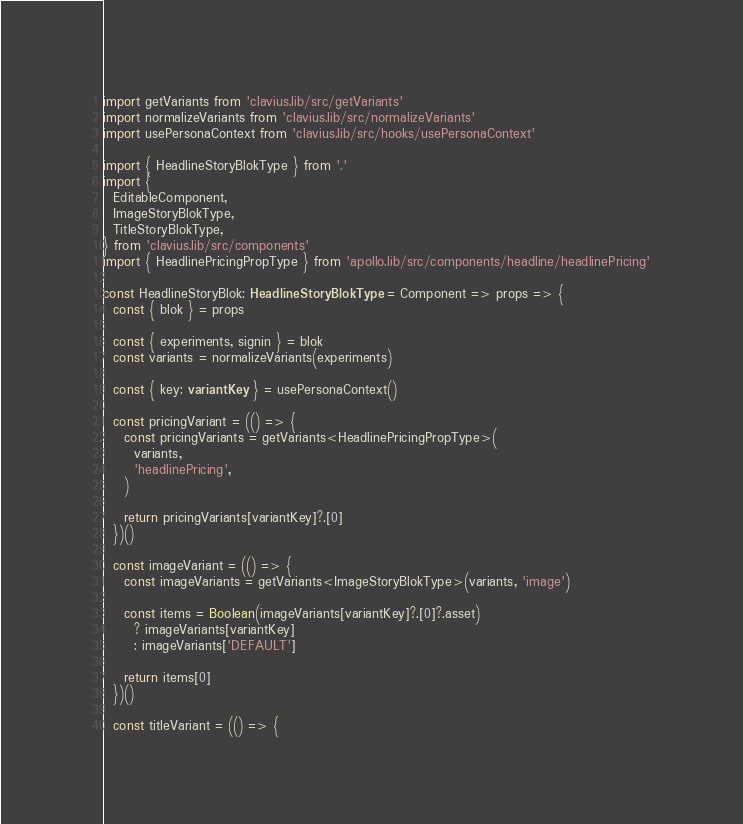<code> <loc_0><loc_0><loc_500><loc_500><_TypeScript_>import getVariants from 'clavius.lib/src/getVariants'
import normalizeVariants from 'clavius.lib/src/normalizeVariants'
import usePersonaContext from 'clavius.lib/src/hooks/usePersonaContext'

import { HeadlineStoryBlokType } from '.'
import {
  EditableComponent,
  ImageStoryBlokType,
  TitleStoryBlokType,
} from 'clavius.lib/src/components'
import { HeadlinePricingPropType } from 'apollo.lib/src/components/headline/headlinePricing'

const HeadlineStoryBlok: HeadlineStoryBlokType = Component => props => {
  const { blok } = props

  const { experiments, signin } = blok
  const variants = normalizeVariants(experiments)

  const { key: variantKey } = usePersonaContext()

  const pricingVariant = (() => {
    const pricingVariants = getVariants<HeadlinePricingPropType>(
      variants,
      'headlinePricing',
    )

    return pricingVariants[variantKey]?.[0]
  })()

  const imageVariant = (() => {
    const imageVariants = getVariants<ImageStoryBlokType>(variants, 'image')

    const items = Boolean(imageVariants[variantKey]?.[0]?.asset)
      ? imageVariants[variantKey]
      : imageVariants['DEFAULT']

    return items[0]
  })()

  const titleVariant = (() => {</code> 